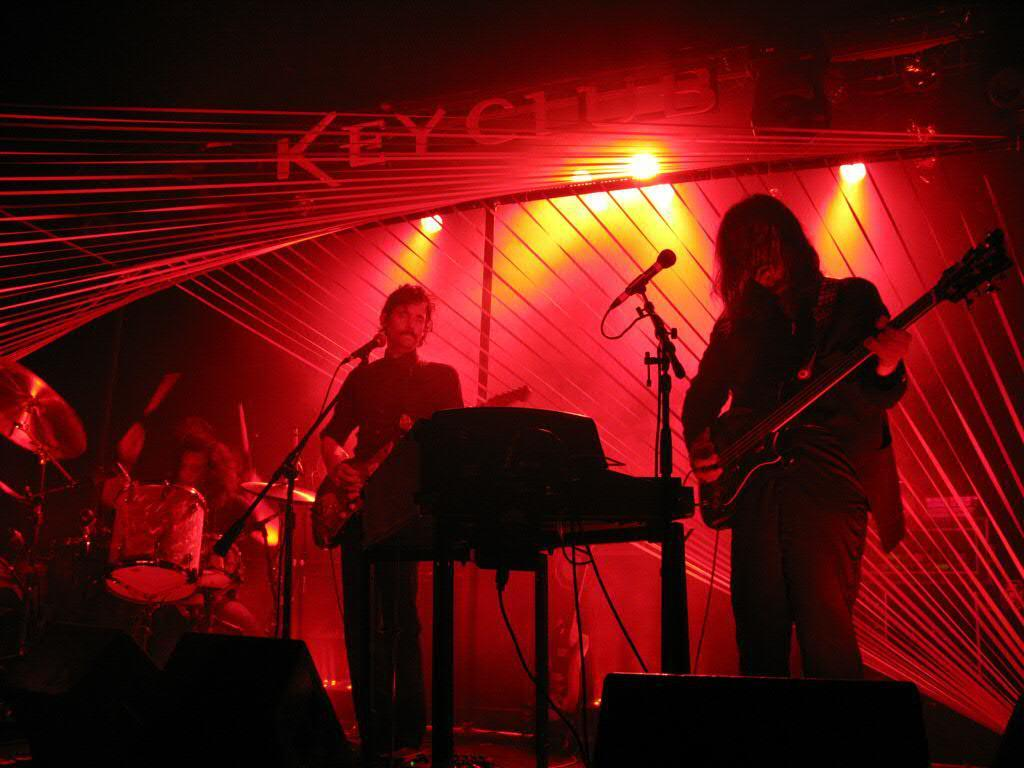Who or what is present in the image? There are people in the image. What are the people doing in the image? The people are playing musical instruments in the image. What tools are used for amplifying sound in the image? There are microphones (mics) in the image. What can be seen providing illumination in the image? There are lights in the image. Can you describe any other objects in the image? There are unspecified objects in the image. What language is being spoken by the iron in the image? There is no iron present in the image, and therefore no language can be spoken by it. How does the health of the people in the image affect their performance? The provided facts do not mention the health of the people in the image, so we cannot determine how it affects their performance. 